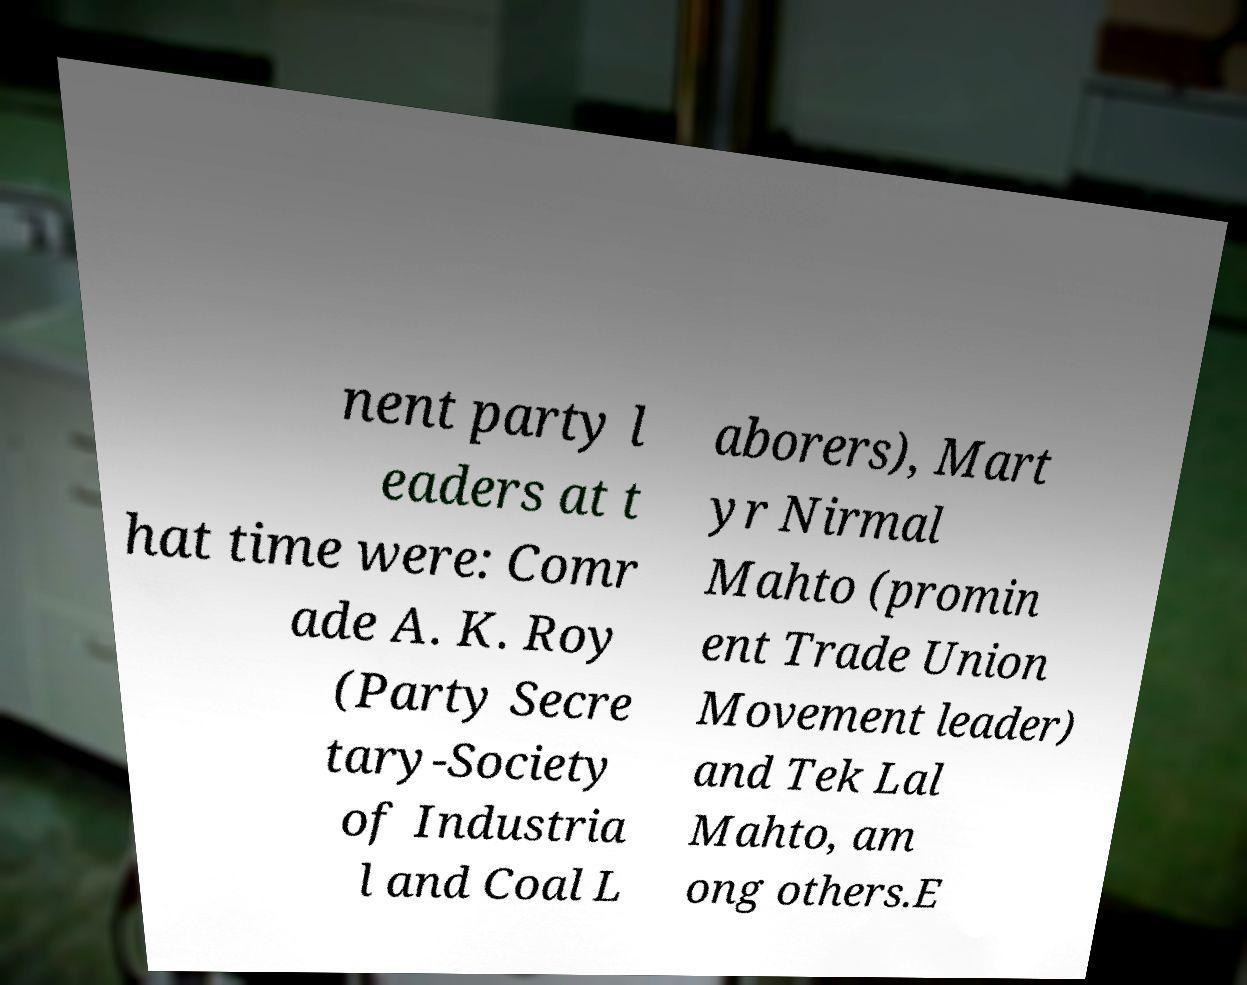Please read and relay the text visible in this image. What does it say? nent party l eaders at t hat time were: Comr ade A. K. Roy (Party Secre tary-Society of Industria l and Coal L aborers), Mart yr Nirmal Mahto (promin ent Trade Union Movement leader) and Tek Lal Mahto, am ong others.E 